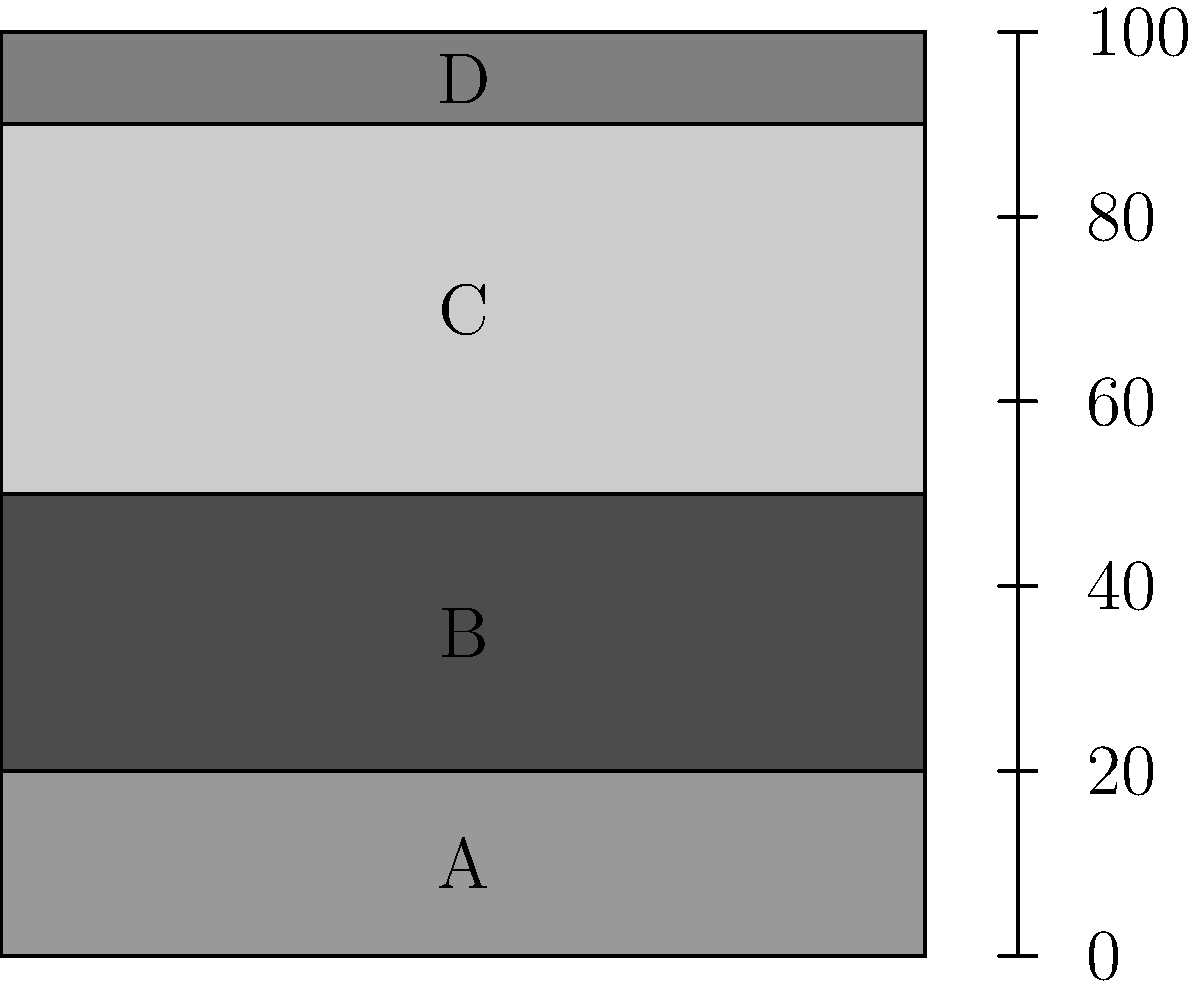Based on the cross-sectional diagram of a reservoir rock sample, rank the layers A, B, C, and D in order of decreasing porosity. Assume that darker shades indicate lower porosity. What implications does this porosity distribution have for potential hydrocarbon accumulation? To answer this question, we need to follow these steps:

1. Interpret the shading:
   - Darker shades indicate lower porosity
   - Lighter shades indicate higher porosity

2. Analyze each layer:
   - Layer A: Medium-light gray
   - Layer B: Dark gray (lowest porosity)
   - Layer C: Light gray (highest porosity)
   - Layer D: Medium gray

3. Rank the layers from highest to lowest porosity:
   C > A > D > B

4. Consider the implications for hydrocarbon accumulation:
   a) Porosity affects the storage capacity of the rock. Higher porosity means more space for hydrocarbons.
   b) Layer C, being the most porous, has the highest potential for hydrocarbon storage.
   c) Layer B, being the least porous, could act as a seal or cap rock, trapping hydrocarbons in the more porous layers below.
   d) The alternating high and low porosity layers create a favorable condition for hydrocarbon trapping.
   e) The sequence C-D-A (high-medium-medium porosity) could form a good reservoir zone.

5. In enhanced oil recovery (EOR) context:
   a) Injected fluids in EOR processes would likely flow more easily through layer C.
   b) Layer B might require fracturing or other stimulation techniques to improve flow.
   c) The porosity variation would affect fluid flow patterns and sweep efficiency in EOR operations.
Answer: Porosity ranking (highest to lowest): C > A > D > B. Implications: Layer C has highest storage potential; Layer B could act as seal; alternating porosity favorable for hydrocarbon trapping; porosity variation affects EOR fluid flow and efficiency. 